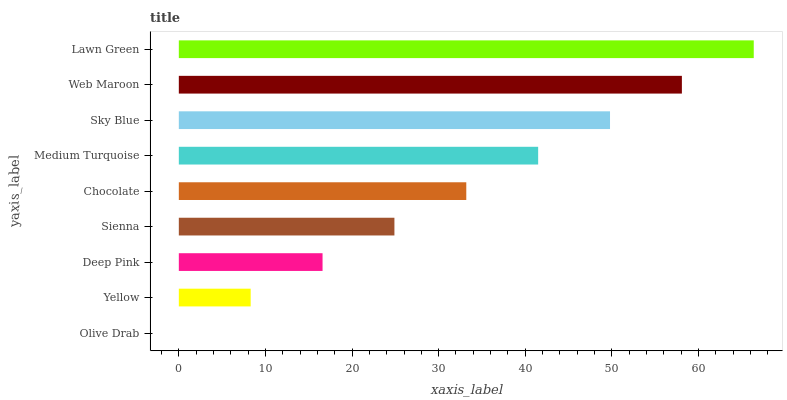Is Olive Drab the minimum?
Answer yes or no. Yes. Is Lawn Green the maximum?
Answer yes or no. Yes. Is Yellow the minimum?
Answer yes or no. No. Is Yellow the maximum?
Answer yes or no. No. Is Yellow greater than Olive Drab?
Answer yes or no. Yes. Is Olive Drab less than Yellow?
Answer yes or no. Yes. Is Olive Drab greater than Yellow?
Answer yes or no. No. Is Yellow less than Olive Drab?
Answer yes or no. No. Is Chocolate the high median?
Answer yes or no. Yes. Is Chocolate the low median?
Answer yes or no. Yes. Is Olive Drab the high median?
Answer yes or no. No. Is Yellow the low median?
Answer yes or no. No. 